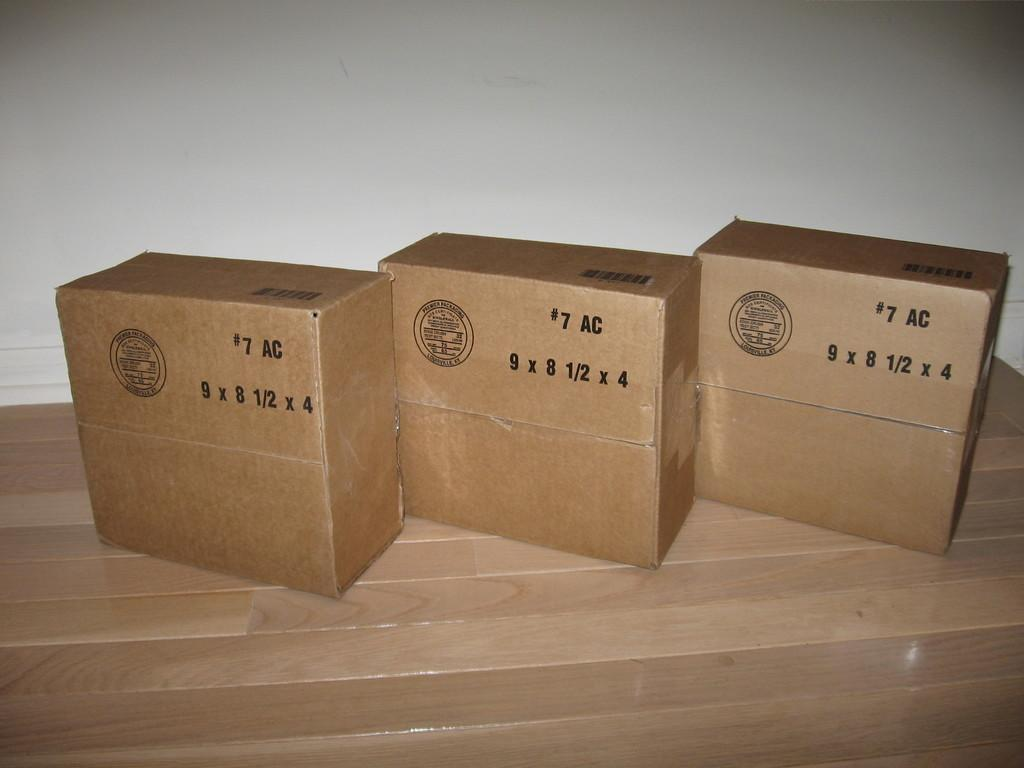<image>
Summarize the visual content of the image. Three large brown cardboxes with the number 7 on them 